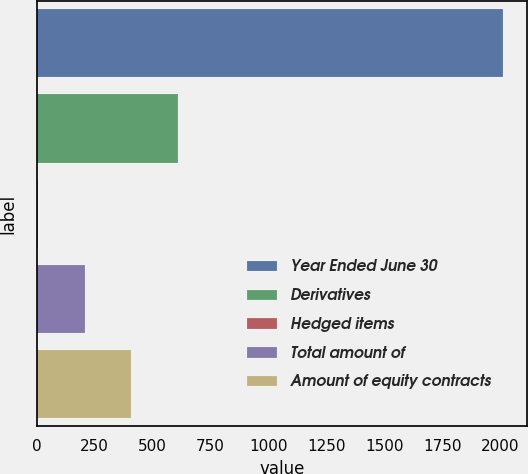<chart> <loc_0><loc_0><loc_500><loc_500><bar_chart><fcel>Year Ended June 30<fcel>Derivatives<fcel>Hedged items<fcel>Total amount of<fcel>Amount of equity contracts<nl><fcel>2014<fcel>608.4<fcel>6<fcel>206.8<fcel>407.6<nl></chart> 